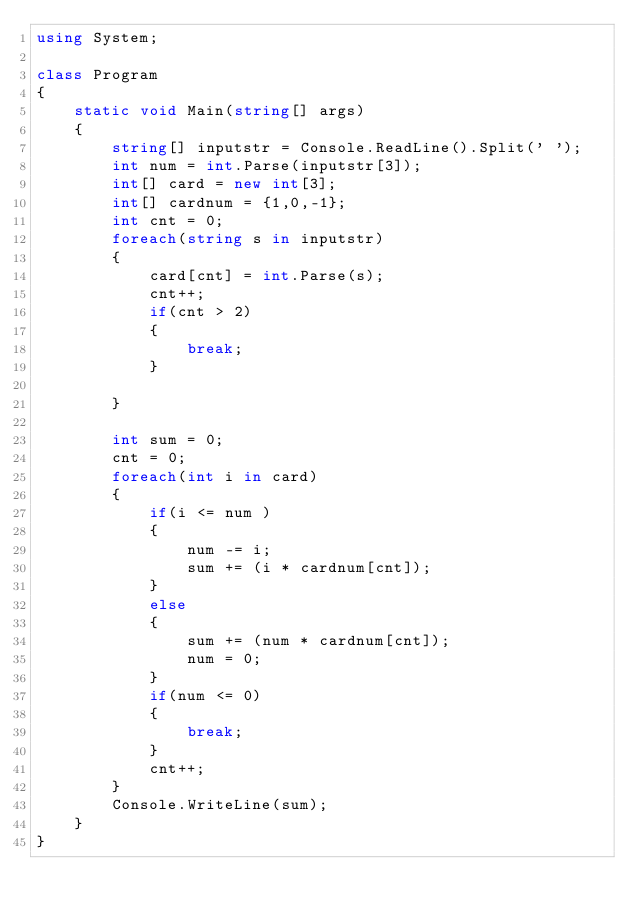<code> <loc_0><loc_0><loc_500><loc_500><_C#_>using System;

class Program
{
    static void Main(string[] args)
    {
        string[] inputstr = Console.ReadLine().Split(' ');
        int num = int.Parse(inputstr[3]);
        int[] card = new int[3];
        int[] cardnum = {1,0,-1};
        int cnt = 0;
        foreach(string s in inputstr)
        {
            card[cnt] = int.Parse(s);
            cnt++;
            if(cnt > 2)
            {
                break;
            }

        }

        int sum = 0;
        cnt = 0;
        foreach(int i in card)
        {
            if(i <= num )
            {
                num -= i;
                sum += (i * cardnum[cnt]);
            }
            else
            {
                sum += (num * cardnum[cnt]);
                num = 0;
            }
            if(num <= 0)
            {
                break;
            }
            cnt++;
        }
        Console.WriteLine(sum);
    }
}</code> 